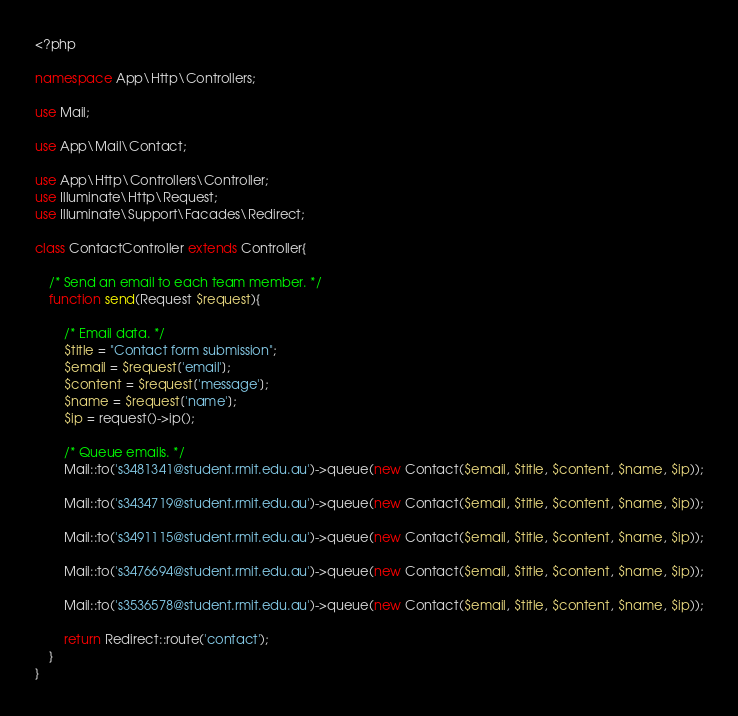<code> <loc_0><loc_0><loc_500><loc_500><_PHP_><?php

namespace App\Http\Controllers;

use Mail;

use App\Mail\Contact;

use App\Http\Controllers\Controller;
use Illuminate\Http\Request;
use Illuminate\Support\Facades\Redirect;

class ContactController extends Controller{

    /* Send an email to each team member. */
    function send(Request $request){

        /* Email data. */
        $title = "Contact form submission";
        $email = $request['email'];
        $content = $request['message'];
        $name = $request['name'];
        $ip = request()->ip();

        /* Queue emails. */
        Mail::to('s3481341@student.rmit.edu.au')->queue(new Contact($email, $title, $content, $name, $ip));

        Mail::to('s3434719@student.rmit.edu.au')->queue(new Contact($email, $title, $content, $name, $ip));

        Mail::to('s3491115@student.rmit.edu.au')->queue(new Contact($email, $title, $content, $name, $ip));

        Mail::to('s3476694@student.rmit.edu.au')->queue(new Contact($email, $title, $content, $name, $ip));

        Mail::to('s3536578@student.rmit.edu.au')->queue(new Contact($email, $title, $content, $name, $ip));

        return Redirect::route('contact');
    }
}
</code> 